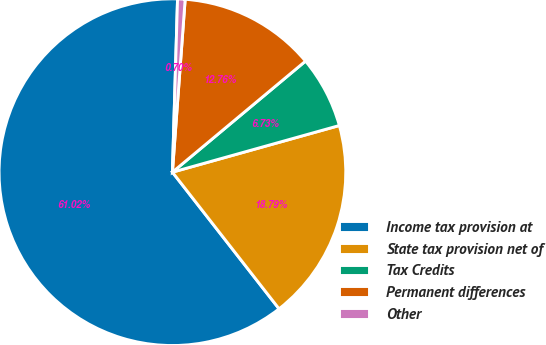<chart> <loc_0><loc_0><loc_500><loc_500><pie_chart><fcel>Income tax provision at<fcel>State tax provision net of<fcel>Tax Credits<fcel>Permanent differences<fcel>Other<nl><fcel>61.02%<fcel>18.79%<fcel>6.73%<fcel>12.76%<fcel>0.7%<nl></chart> 